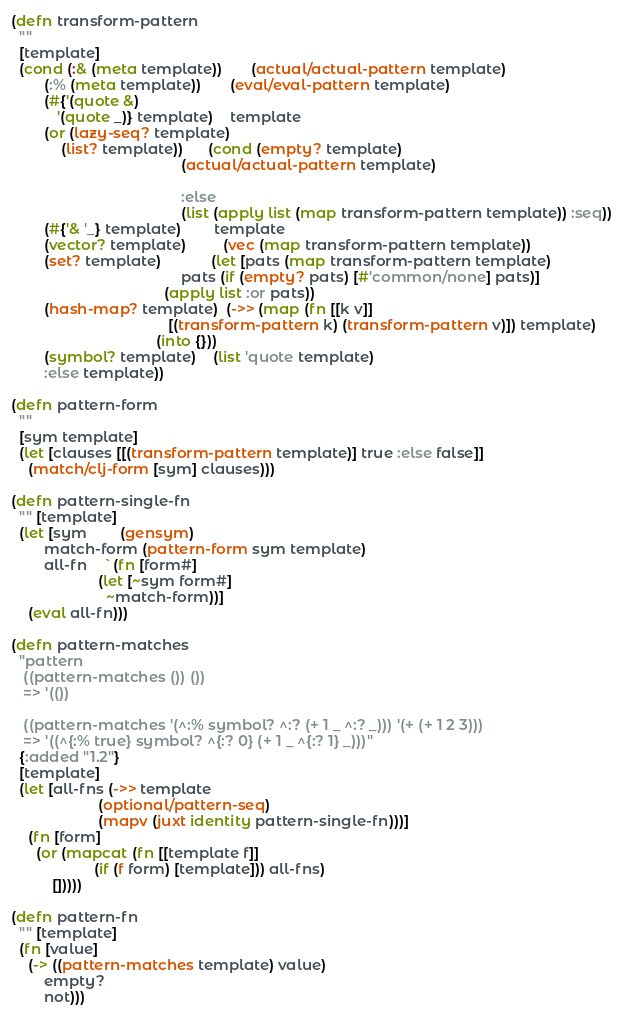Convert code to text. <code><loc_0><loc_0><loc_500><loc_500><_Clojure_>
(defn transform-pattern
  ""
  [template]
  (cond (:& (meta template))       (actual/actual-pattern template)
        (:% (meta template))       (eval/eval-pattern template)
        (#{'(quote &)
           '(quote _)} template)    template
        (or (lazy-seq? template)
            (list? template))      (cond (empty? template)
                                         (actual/actual-pattern template)

                                         :else
                                         (list (apply list (map transform-pattern template)) :seq))    
        (#{'& '_} template)        template
        (vector? template)         (vec (map transform-pattern template))
        (set? template)            (let [pats (map transform-pattern template)
                                         pats (if (empty? pats) [#'common/none] pats)]
                                     (apply list :or pats))
        (hash-map? template)  (->> (map (fn [[k v]]
                                      [(transform-pattern k) (transform-pattern v)]) template)
                                   (into {}))
        (symbol? template)    (list 'quote template)
        :else template))

(defn pattern-form
  ""
  [sym template]
  (let [clauses [[(transform-pattern template)] true :else false]]
    (match/clj-form [sym] clauses)))

(defn pattern-single-fn
  "" [template]
  (let [sym        (gensym)
        match-form (pattern-form sym template)
        all-fn    `(fn [form#]
                     (let [~sym form#]
                       ~match-form))]
    (eval all-fn)))

(defn pattern-matches
  "pattern
   ((pattern-matches ()) ())
   => '(())
   
   ((pattern-matches '(^:% symbol? ^:? (+ 1 _ ^:? _))) '(+ (+ 1 2 3)))
   => '((^{:% true} symbol? ^{:? 0} (+ 1 _ ^{:? 1} _)))"
  {:added "1.2"}
  [template]
  (let [all-fns (->> template
                     (optional/pattern-seq)
                     (mapv (juxt identity pattern-single-fn)))]
    (fn [form]
      (or (mapcat (fn [[template f]]
                    (if (f form) [template])) all-fns)
          []))))

(defn pattern-fn
  "" [template]
  (fn [value]
    (-> ((pattern-matches template) value)
        empty?
        not)))
</code> 